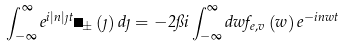Convert formula to latex. <formula><loc_0><loc_0><loc_500><loc_500>\int _ { - \infty } ^ { \infty } e ^ { i \left | n \right | \eta t } \psi _ { \pm } \left ( \eta \right ) d \eta = - 2 \pi i \int _ { - \infty } ^ { \infty } d w f _ { e , v } \left ( w \right ) e ^ { - i n w t }</formula> 